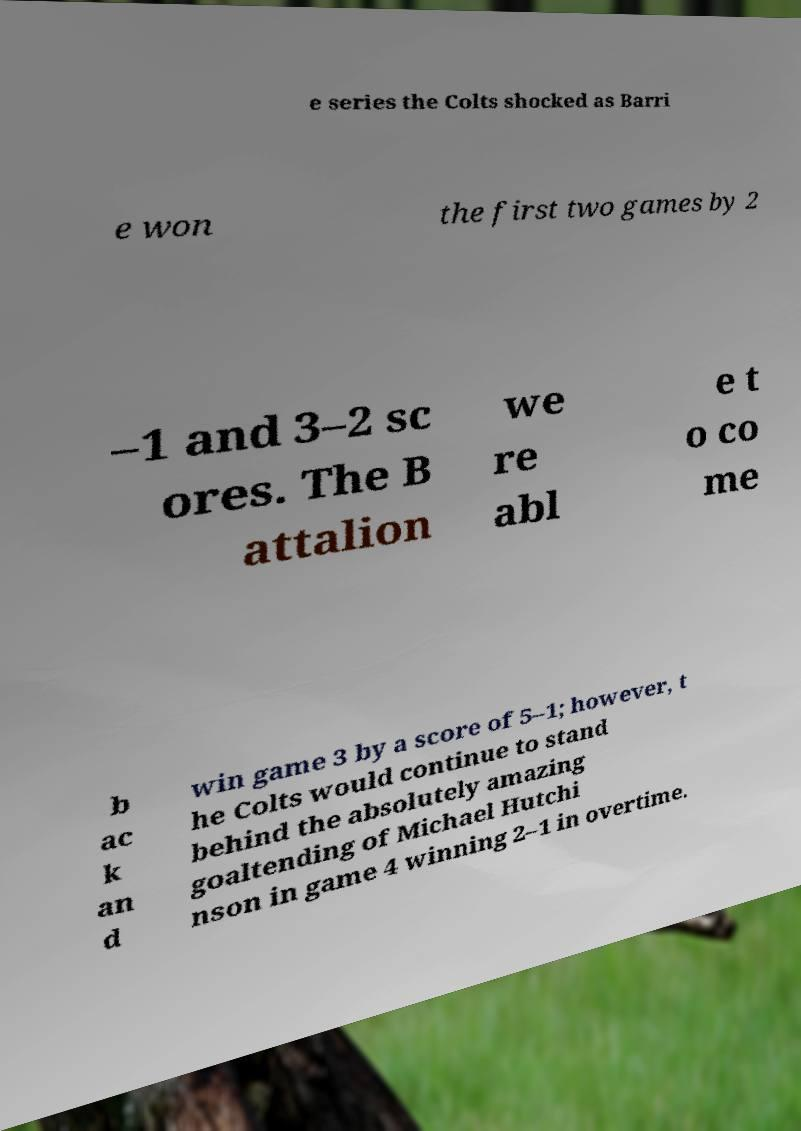Please identify and transcribe the text found in this image. e series the Colts shocked as Barri e won the first two games by 2 –1 and 3–2 sc ores. The B attalion we re abl e t o co me b ac k an d win game 3 by a score of 5–1; however, t he Colts would continue to stand behind the absolutely amazing goaltending of Michael Hutchi nson in game 4 winning 2–1 in overtime. 